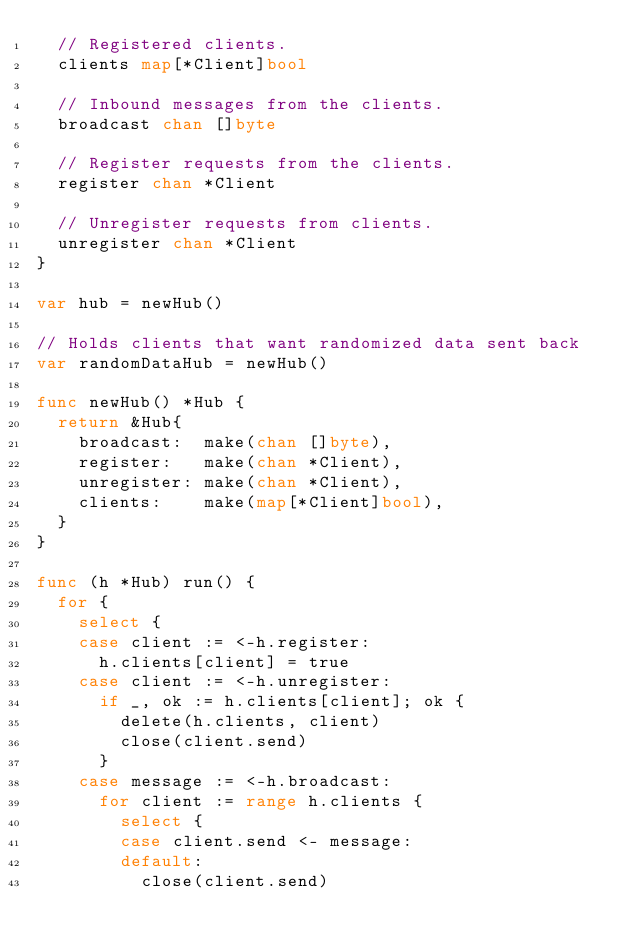<code> <loc_0><loc_0><loc_500><loc_500><_Go_>	// Registered clients.
	clients map[*Client]bool

	// Inbound messages from the clients.
	broadcast chan []byte

	// Register requests from the clients.
	register chan *Client

	// Unregister requests from clients.
	unregister chan *Client
}

var hub = newHub()

// Holds clients that want randomized data sent back
var randomDataHub = newHub()

func newHub() *Hub {
	return &Hub{
		broadcast:  make(chan []byte),
		register:   make(chan *Client),
		unregister: make(chan *Client),
		clients:    make(map[*Client]bool),
	}
}

func (h *Hub) run() {
	for {
		select {
		case client := <-h.register:
			h.clients[client] = true
		case client := <-h.unregister:
			if _, ok := h.clients[client]; ok {
				delete(h.clients, client)
				close(client.send)
			}
		case message := <-h.broadcast:
			for client := range h.clients {
				select {
				case client.send <- message:
				default:
					close(client.send)</code> 